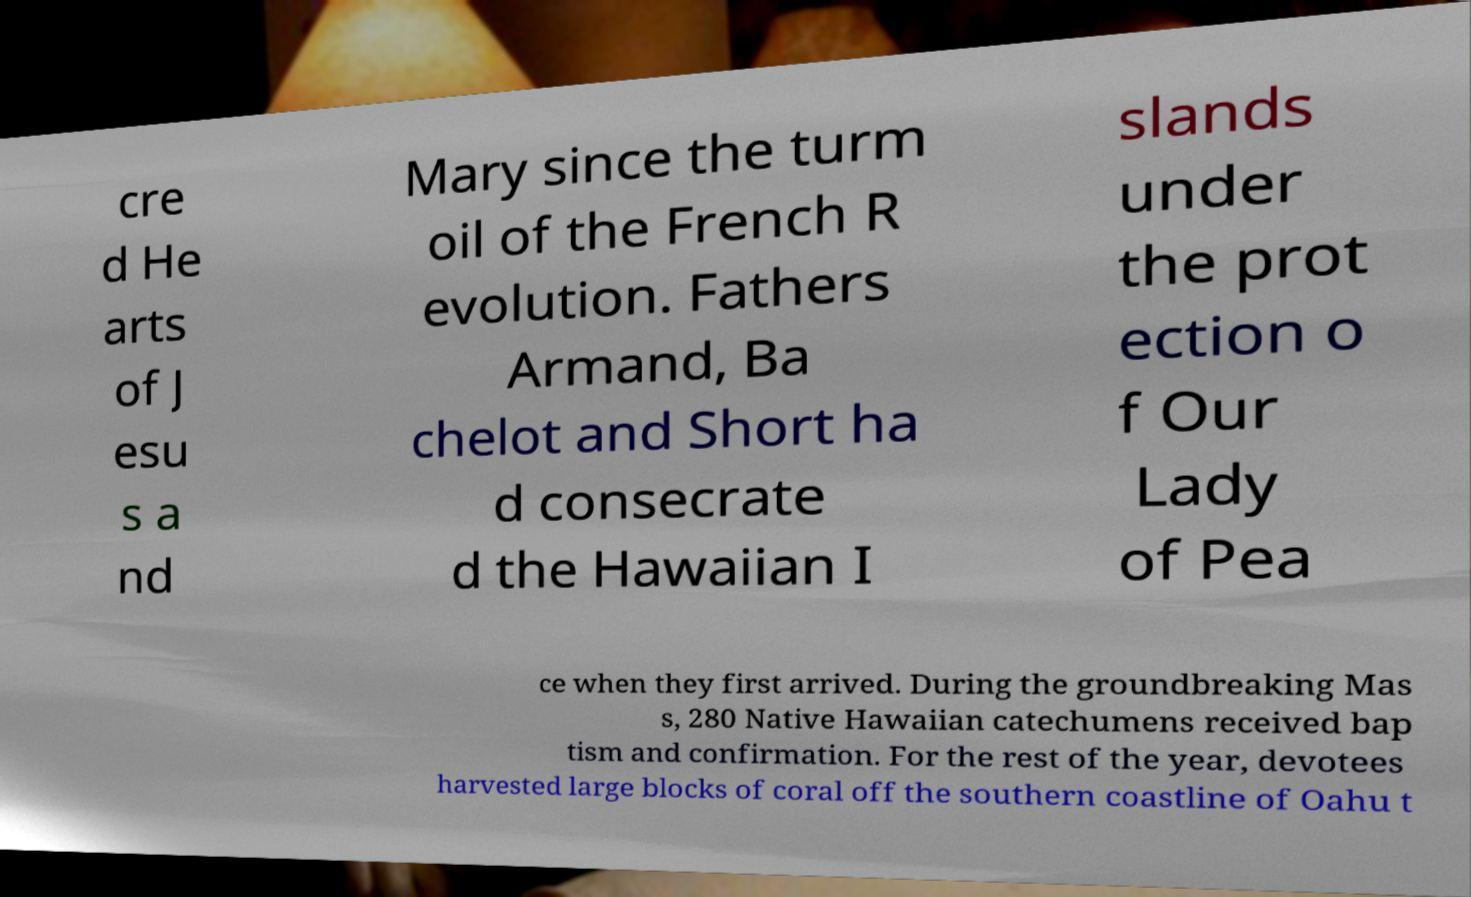I need the written content from this picture converted into text. Can you do that? cre d He arts of J esu s a nd Mary since the turm oil of the French R evolution. Fathers Armand, Ba chelot and Short ha d consecrate d the Hawaiian I slands under the prot ection o f Our Lady of Pea ce when they first arrived. During the groundbreaking Mas s, 280 Native Hawaiian catechumens received bap tism and confirmation. For the rest of the year, devotees harvested large blocks of coral off the southern coastline of Oahu t 